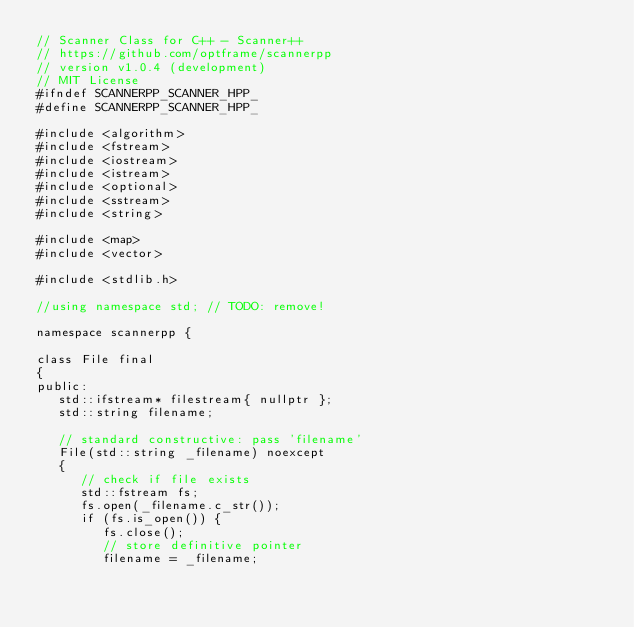Convert code to text. <code><loc_0><loc_0><loc_500><loc_500><_C++_>// Scanner Class for C++ - Scanner++
// https://github.com/optframe/scannerpp
// version v1.0.4 (development)
// MIT License
#ifndef SCANNERPP_SCANNER_HPP_
#define SCANNERPP_SCANNER_HPP_

#include <algorithm>
#include <fstream>
#include <iostream>
#include <istream>
#include <optional>
#include <sstream>
#include <string>

#include <map>
#include <vector>

#include <stdlib.h>

//using namespace std; // TODO: remove!

namespace scannerpp {

class File final
{
public:
   std::ifstream* filestream{ nullptr };
   std::string filename;

   // standard constructive: pass 'filename'
   File(std::string _filename) noexcept
   {
      // check if file exists
      std::fstream fs;
      fs.open(_filename.c_str());
      if (fs.is_open()) {
         fs.close();
         // store definitive pointer
         filename = _filename;</code> 